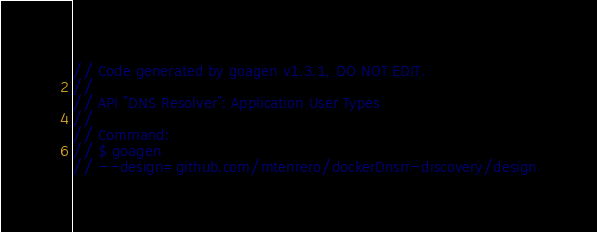<code> <loc_0><loc_0><loc_500><loc_500><_Go_>// Code generated by goagen v1.3.1, DO NOT EDIT.
//
// API "DNS Resolver": Application User Types
//
// Command:
// $ goagen
// --design=github.com/mtenrero/dockerDnsrr-discovery/design</code> 